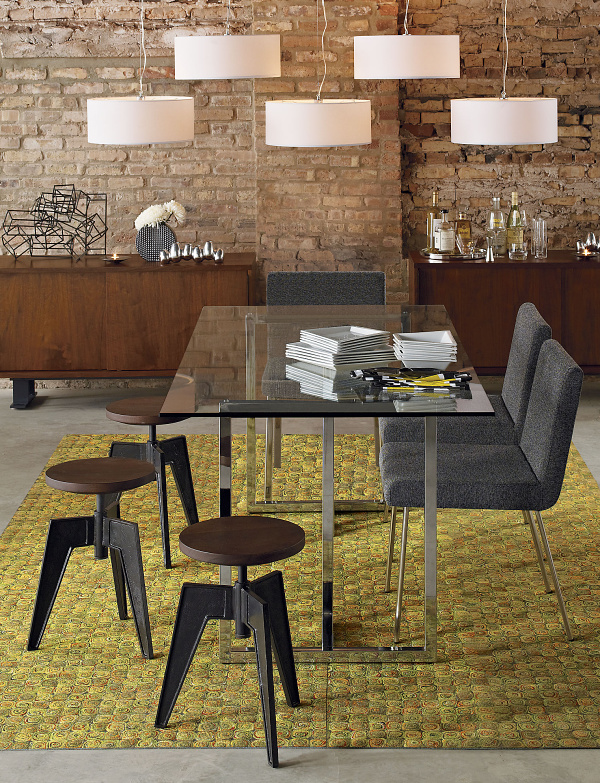How many diningtables are there in the image? 1 